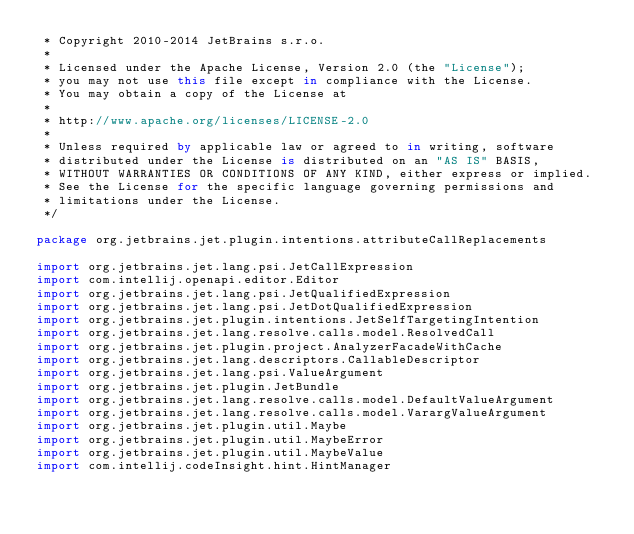<code> <loc_0><loc_0><loc_500><loc_500><_Kotlin_> * Copyright 2010-2014 JetBrains s.r.o.
 *
 * Licensed under the Apache License, Version 2.0 (the "License");
 * you may not use this file except in compliance with the License.
 * You may obtain a copy of the License at
 *
 * http://www.apache.org/licenses/LICENSE-2.0
 *
 * Unless required by applicable law or agreed to in writing, software
 * distributed under the License is distributed on an "AS IS" BASIS,
 * WITHOUT WARRANTIES OR CONDITIONS OF ANY KIND, either express or implied.
 * See the License for the specific language governing permissions and
 * limitations under the License.
 */

package org.jetbrains.jet.plugin.intentions.attributeCallReplacements

import org.jetbrains.jet.lang.psi.JetCallExpression
import com.intellij.openapi.editor.Editor
import org.jetbrains.jet.lang.psi.JetQualifiedExpression
import org.jetbrains.jet.lang.psi.JetDotQualifiedExpression
import org.jetbrains.jet.plugin.intentions.JetSelfTargetingIntention
import org.jetbrains.jet.lang.resolve.calls.model.ResolvedCall
import org.jetbrains.jet.plugin.project.AnalyzerFacadeWithCache
import org.jetbrains.jet.lang.descriptors.CallableDescriptor
import org.jetbrains.jet.lang.psi.ValueArgument
import org.jetbrains.jet.plugin.JetBundle
import org.jetbrains.jet.lang.resolve.calls.model.DefaultValueArgument
import org.jetbrains.jet.lang.resolve.calls.model.VarargValueArgument
import org.jetbrains.jet.plugin.util.Maybe
import org.jetbrains.jet.plugin.util.MaybeError
import org.jetbrains.jet.plugin.util.MaybeValue
import com.intellij.codeInsight.hint.HintManager</code> 